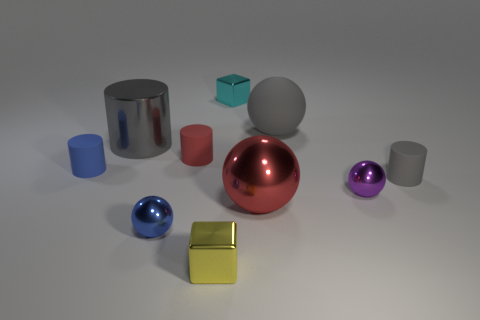Is the shape of the large red shiny object the same as the purple object?
Your answer should be compact. Yes. How many cyan things have the same size as the gray sphere?
Offer a very short reply. 0. Are there fewer tiny red things on the right side of the red cylinder than big purple cylinders?
Your response must be concise. No. How big is the block that is behind the metallic object that is to the right of the large matte object?
Ensure brevity in your answer.  Small. What number of things are tiny cyan objects or large blue matte cubes?
Give a very brief answer. 1. Is there another cylinder that has the same color as the big cylinder?
Your answer should be very brief. Yes. Is the number of tiny gray matte cylinders less than the number of tiny spheres?
Offer a very short reply. Yes. What number of things are gray rubber cylinders or tiny objects behind the tiny red matte cylinder?
Offer a very short reply. 2. Is there a large cube that has the same material as the cyan thing?
Your answer should be very brief. No. There is a red ball that is the same size as the shiny cylinder; what is it made of?
Give a very brief answer. Metal. 